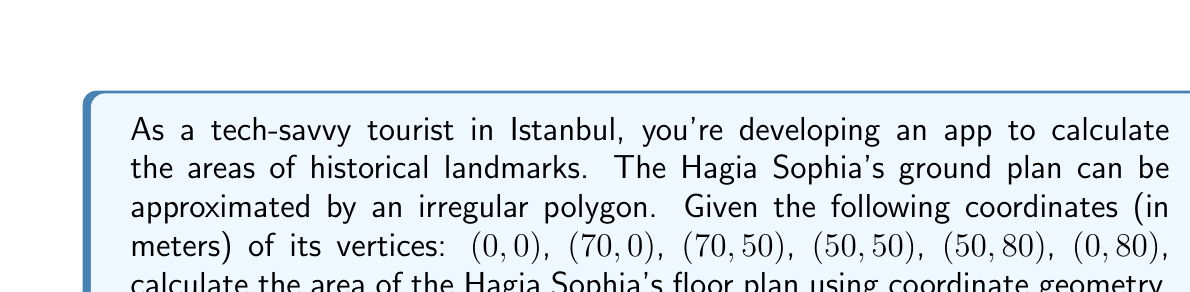Give your solution to this math problem. To find the area of this irregular polygon, we can use the Shoelace formula (also known as the surveyor's formula). The steps are as follows:

1) List the coordinates in order, repeating the first coordinate at the end:
   $(0,0)$, $(70,0)$, $(70,50)$, $(50,50)$, $(50,80)$, $(0,80)$, $(0,0)$

2) Apply the Shoelace formula:
   $$A = \frac{1}{2}|(x_1y_2 + x_2y_3 + ... + x_ny_1) - (y_1x_2 + y_2x_3 + ... + y_nx_1)|$$

3) Calculate each term:
   $$(0 \cdot 0) + (70 \cdot 50) + (70 \cdot 50) + (50 \cdot 80) + (50 \cdot 80) + (0 \cdot 0) = 11000$$
   $$(0 \cdot 70) + (0 \cdot 70) + (50 \cdot 50) + (50 \cdot 50) + (80 \cdot 0) + (80 \cdot 0) = 5000$$

4) Subtract and take the absolute value:
   $$|11000 - 5000| = 6000$$

5) Divide by 2:
   $$\frac{6000}{2} = 3000$$

Therefore, the area of the Hagia Sophia's floor plan is 3000 square meters.
Answer: 3000 m² 